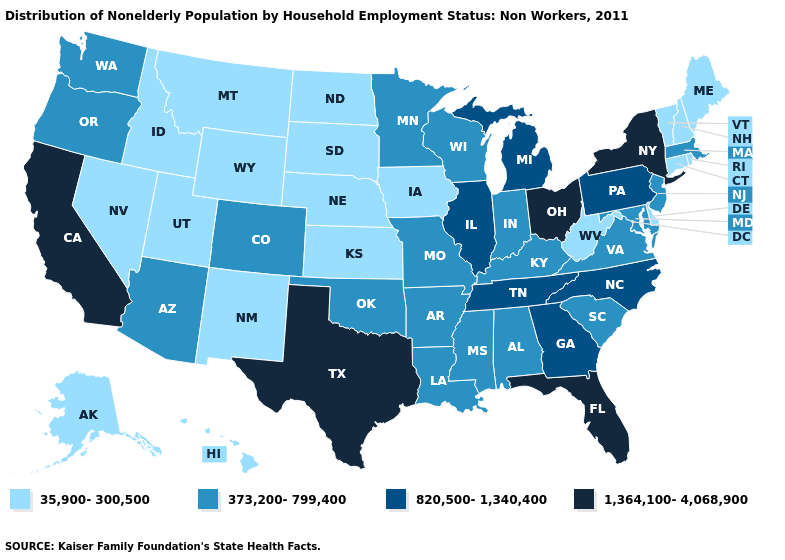Does Vermont have the highest value in the USA?
Answer briefly. No. Name the states that have a value in the range 35,900-300,500?
Quick response, please. Alaska, Connecticut, Delaware, Hawaii, Idaho, Iowa, Kansas, Maine, Montana, Nebraska, Nevada, New Hampshire, New Mexico, North Dakota, Rhode Island, South Dakota, Utah, Vermont, West Virginia, Wyoming. What is the value of Kansas?
Answer briefly. 35,900-300,500. What is the value of California?
Answer briefly. 1,364,100-4,068,900. Does Texas have the highest value in the USA?
Write a very short answer. Yes. What is the value of Illinois?
Keep it brief. 820,500-1,340,400. Does Massachusetts have a higher value than Ohio?
Be succinct. No. What is the highest value in states that border Nebraska?
Write a very short answer. 373,200-799,400. What is the value of Connecticut?
Keep it brief. 35,900-300,500. What is the value of Connecticut?
Short answer required. 35,900-300,500. Name the states that have a value in the range 820,500-1,340,400?
Quick response, please. Georgia, Illinois, Michigan, North Carolina, Pennsylvania, Tennessee. Among the states that border Washington , does Idaho have the highest value?
Keep it brief. No. What is the value of Missouri?
Write a very short answer. 373,200-799,400. What is the value of Kentucky?
Write a very short answer. 373,200-799,400. What is the highest value in the USA?
Be succinct. 1,364,100-4,068,900. 